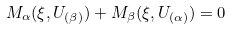Convert formula to latex. <formula><loc_0><loc_0><loc_500><loc_500>M _ { \alpha } ( \xi , U _ { ( \beta ) } ) + M _ { \beta } ( \xi , U _ { ( \alpha ) } ) = 0</formula> 